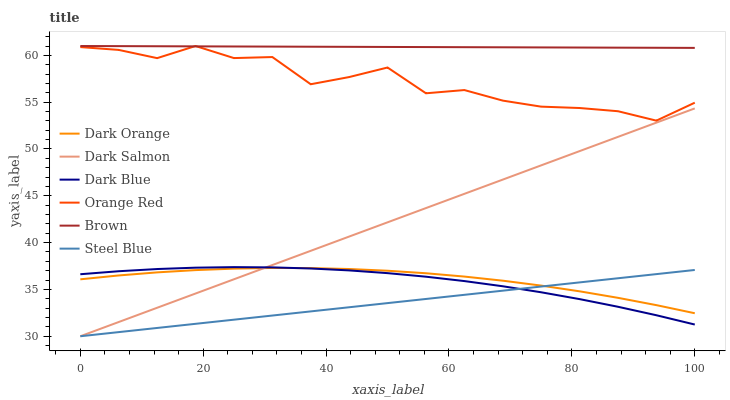Does Steel Blue have the minimum area under the curve?
Answer yes or no. Yes. Does Brown have the maximum area under the curve?
Answer yes or no. Yes. Does Dark Orange have the minimum area under the curve?
Answer yes or no. No. Does Dark Orange have the maximum area under the curve?
Answer yes or no. No. Is Brown the smoothest?
Answer yes or no. Yes. Is Orange Red the roughest?
Answer yes or no. Yes. Is Dark Orange the smoothest?
Answer yes or no. No. Is Dark Orange the roughest?
Answer yes or no. No. Does Dark Orange have the lowest value?
Answer yes or no. No. Does Orange Red have the highest value?
Answer yes or no. Yes. Does Dark Orange have the highest value?
Answer yes or no. No. Is Dark Blue less than Brown?
Answer yes or no. Yes. Is Orange Red greater than Steel Blue?
Answer yes or no. Yes. Does Dark Blue intersect Dark Orange?
Answer yes or no. Yes. Is Dark Blue less than Dark Orange?
Answer yes or no. No. Is Dark Blue greater than Dark Orange?
Answer yes or no. No. Does Dark Blue intersect Brown?
Answer yes or no. No. 